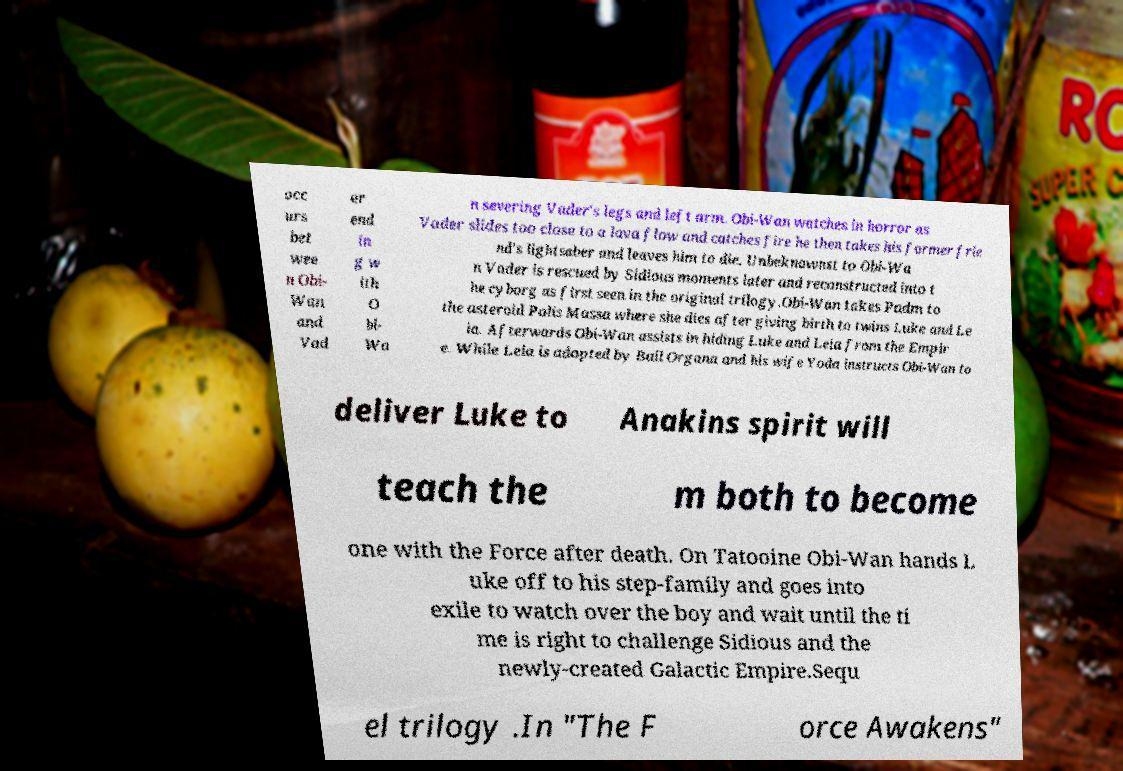Please identify and transcribe the text found in this image. occ urs bet wee n Obi- Wan and Vad er end in g w ith O bi- Wa n severing Vader's legs and left arm. Obi-Wan watches in horror as Vader slides too close to a lava flow and catches fire he then takes his former frie nd's lightsaber and leaves him to die. Unbeknownst to Obi-Wa n Vader is rescued by Sidious moments later and reconstructed into t he cyborg as first seen in the original trilogy.Obi-Wan takes Padm to the asteroid Polis Massa where she dies after giving birth to twins Luke and Le ia. Afterwards Obi-Wan assists in hiding Luke and Leia from the Empir e. While Leia is adopted by Bail Organa and his wife Yoda instructs Obi-Wan to deliver Luke to Anakins spirit will teach the m both to become one with the Force after death. On Tatooine Obi-Wan hands L uke off to his step-family and goes into exile to watch over the boy and wait until the ti me is right to challenge Sidious and the newly-created Galactic Empire.Sequ el trilogy .In "The F orce Awakens" 